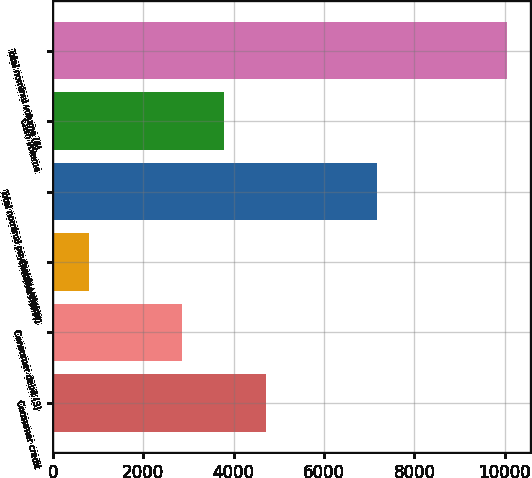Convert chart to OTSL. <chart><loc_0><loc_0><loc_500><loc_500><bar_chart><fcel>Consumer credit<fcel>Consumer debit (3)<fcel>Commercial (4)<fcel>Total nominal payments volume<fcel>Cash volume<fcel>Total nominal volume (6)<nl><fcel>4712.4<fcel>2864<fcel>812<fcel>7162<fcel>3788.2<fcel>10054<nl></chart> 